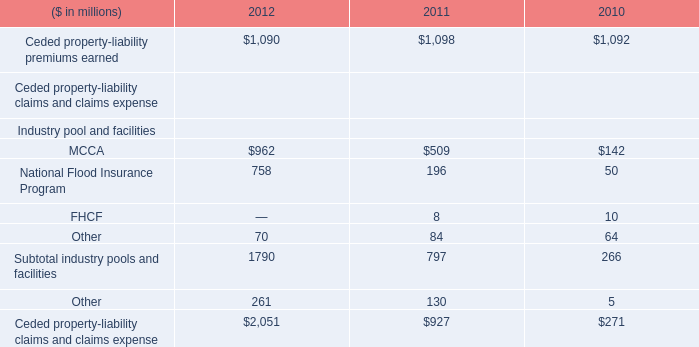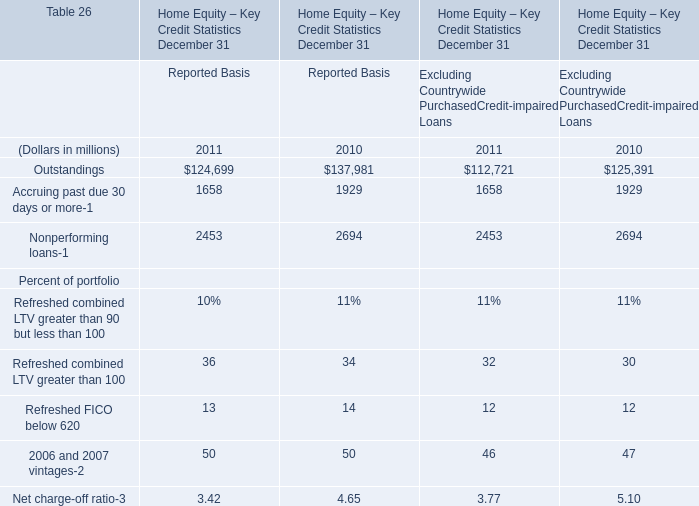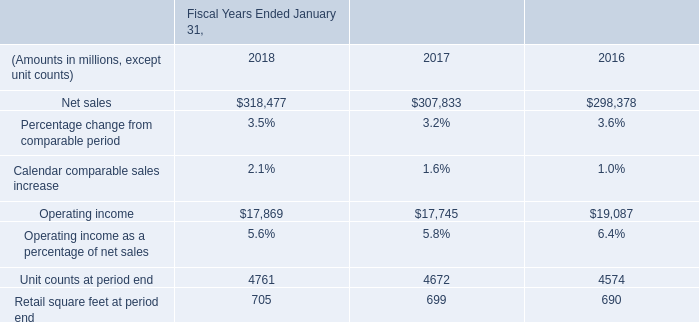Which year is Nonperforming loans for Reported Basis the least ? 
Answer: 2011. 